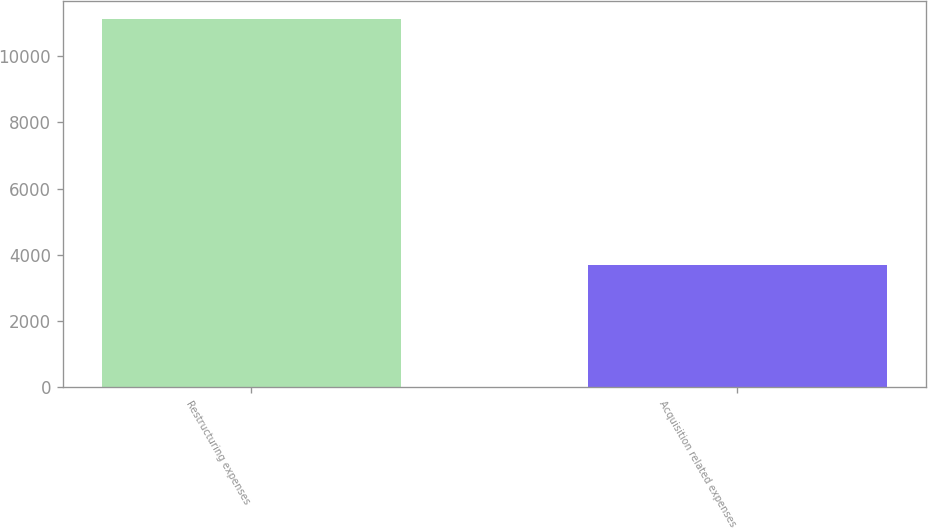Convert chart to OTSL. <chart><loc_0><loc_0><loc_500><loc_500><bar_chart><fcel>Restructuring expenses<fcel>Acquisition related expenses<nl><fcel>11123<fcel>3683<nl></chart> 